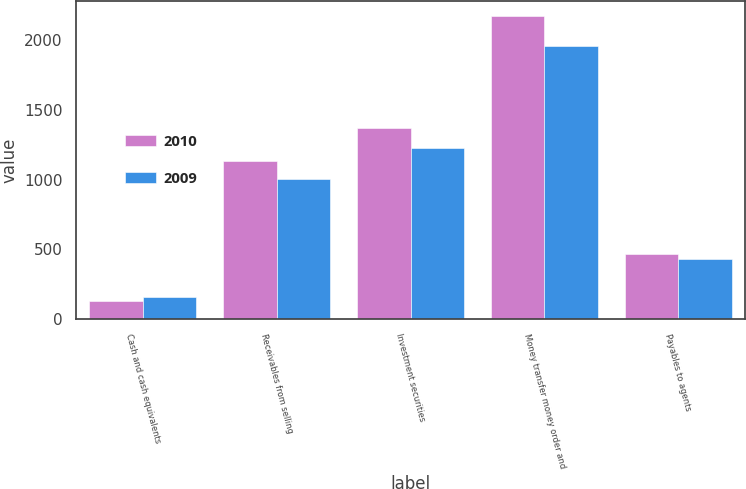Convert chart to OTSL. <chart><loc_0><loc_0><loc_500><loc_500><stacked_bar_chart><ecel><fcel>Cash and cash equivalents<fcel>Receivables from selling<fcel>Investment securities<fcel>Money transfer money order and<fcel>Payables to agents<nl><fcel>2010<fcel>133.8<fcel>1132.3<fcel>1369.1<fcel>2170<fcel>465.2<nl><fcel>2009<fcel>161.9<fcel>1004.4<fcel>1222.8<fcel>1954.8<fcel>434.3<nl></chart> 